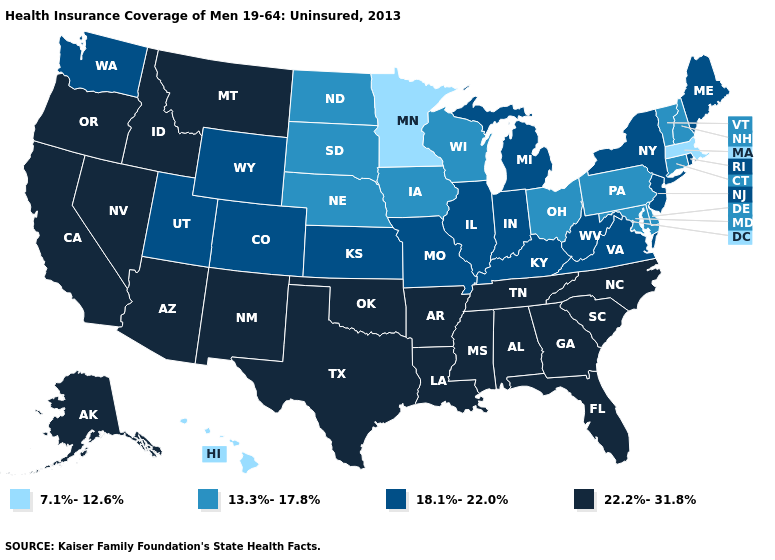Name the states that have a value in the range 13.3%-17.8%?
Give a very brief answer. Connecticut, Delaware, Iowa, Maryland, Nebraska, New Hampshire, North Dakota, Ohio, Pennsylvania, South Dakota, Vermont, Wisconsin. What is the highest value in states that border Delaware?
Quick response, please. 18.1%-22.0%. Among the states that border New Hampshire , which have the lowest value?
Answer briefly. Massachusetts. Does Missouri have a higher value than Utah?
Keep it brief. No. Name the states that have a value in the range 22.2%-31.8%?
Concise answer only. Alabama, Alaska, Arizona, Arkansas, California, Florida, Georgia, Idaho, Louisiana, Mississippi, Montana, Nevada, New Mexico, North Carolina, Oklahoma, Oregon, South Carolina, Tennessee, Texas. Name the states that have a value in the range 22.2%-31.8%?
Write a very short answer. Alabama, Alaska, Arizona, Arkansas, California, Florida, Georgia, Idaho, Louisiana, Mississippi, Montana, Nevada, New Mexico, North Carolina, Oklahoma, Oregon, South Carolina, Tennessee, Texas. What is the value of Oregon?
Give a very brief answer. 22.2%-31.8%. What is the value of Maine?
Be succinct. 18.1%-22.0%. Does Oklahoma have a higher value than Oregon?
Write a very short answer. No. Does Mississippi have the lowest value in the South?
Answer briefly. No. Does Louisiana have a lower value than Minnesota?
Quick response, please. No. What is the value of Hawaii?
Give a very brief answer. 7.1%-12.6%. Among the states that border Indiana , does Michigan have the lowest value?
Be succinct. No. Which states hav the highest value in the West?
Write a very short answer. Alaska, Arizona, California, Idaho, Montana, Nevada, New Mexico, Oregon. Name the states that have a value in the range 13.3%-17.8%?
Quick response, please. Connecticut, Delaware, Iowa, Maryland, Nebraska, New Hampshire, North Dakota, Ohio, Pennsylvania, South Dakota, Vermont, Wisconsin. 